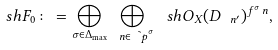Convert formula to latex. <formula><loc_0><loc_0><loc_500><loc_500>\ s h { F } _ { 0 } \colon = \bigoplus _ { \sigma \in \Delta _ { \max } } \bigoplus _ { \ n \in \tilde { \ p } ^ { \sigma } } \ s h { O } _ { X } ( D _ { \ n ^ { \prime } } ) ^ { f ^ { \sigma } _ { \ } n } ,</formula> 